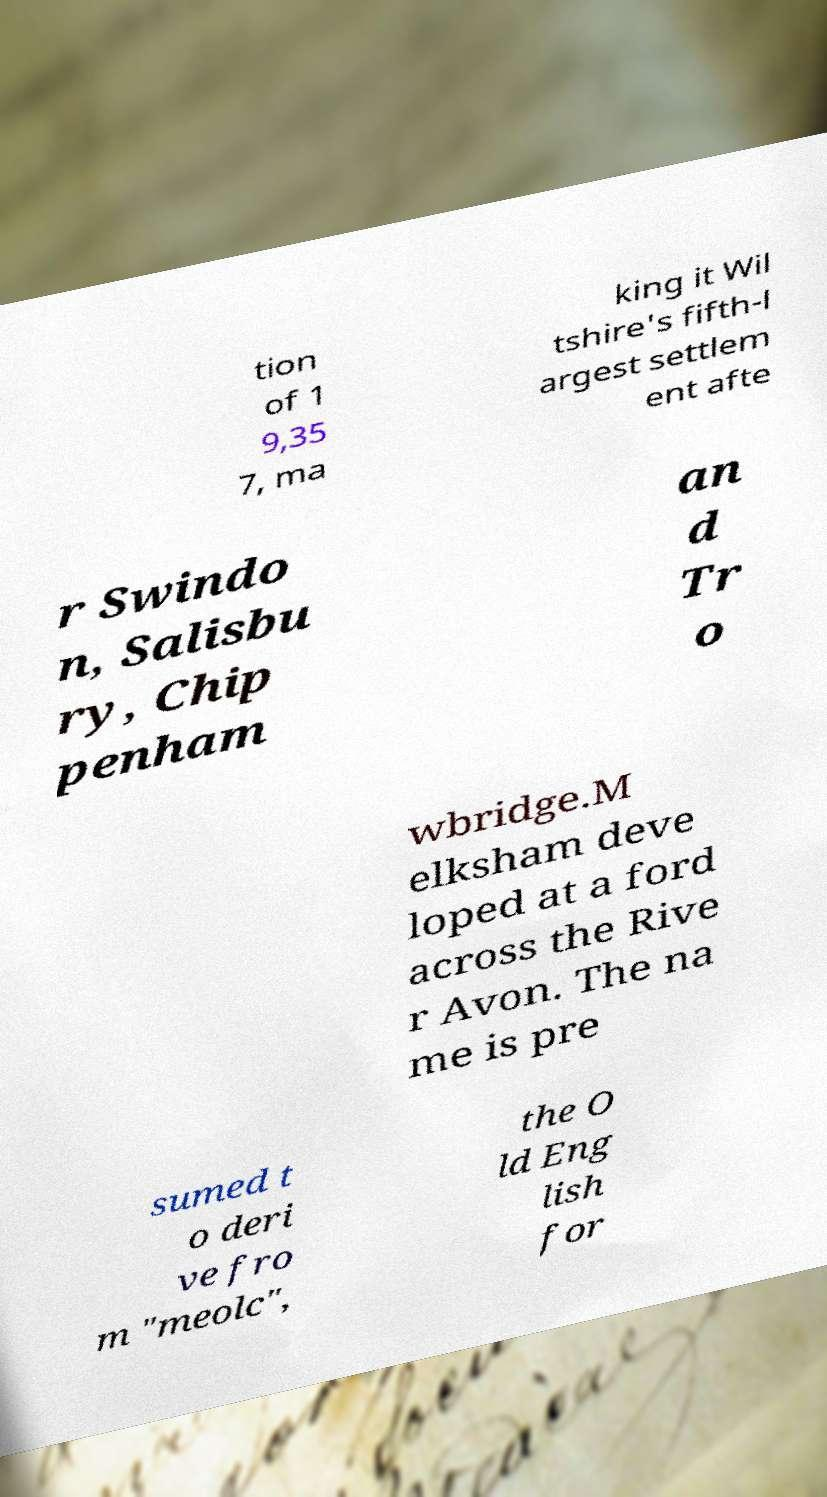What messages or text are displayed in this image? I need them in a readable, typed format. tion of 1 9,35 7, ma king it Wil tshire's fifth-l argest settlem ent afte r Swindo n, Salisbu ry, Chip penham an d Tr o wbridge.M elksham deve loped at a ford across the Rive r Avon. The na me is pre sumed t o deri ve fro m "meolc", the O ld Eng lish for 